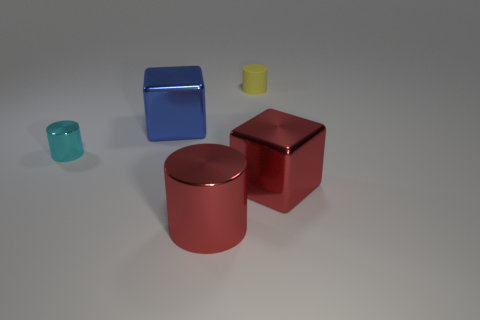Can you describe the difference in texture between the objects? Certainly! The small semi-transparent, bluish-green object has a slightly frosted, glass-like texture. The large blue cube and the big cylinder both exhibit a shiny, metallic finish that reflects light smoothly. The yellow object seems to have a matte, less reflective texture, possibly rubber or plastic. Lastly, the big red cube shares the metallic finish that the larger cylinder has, suggesting a similar material. 